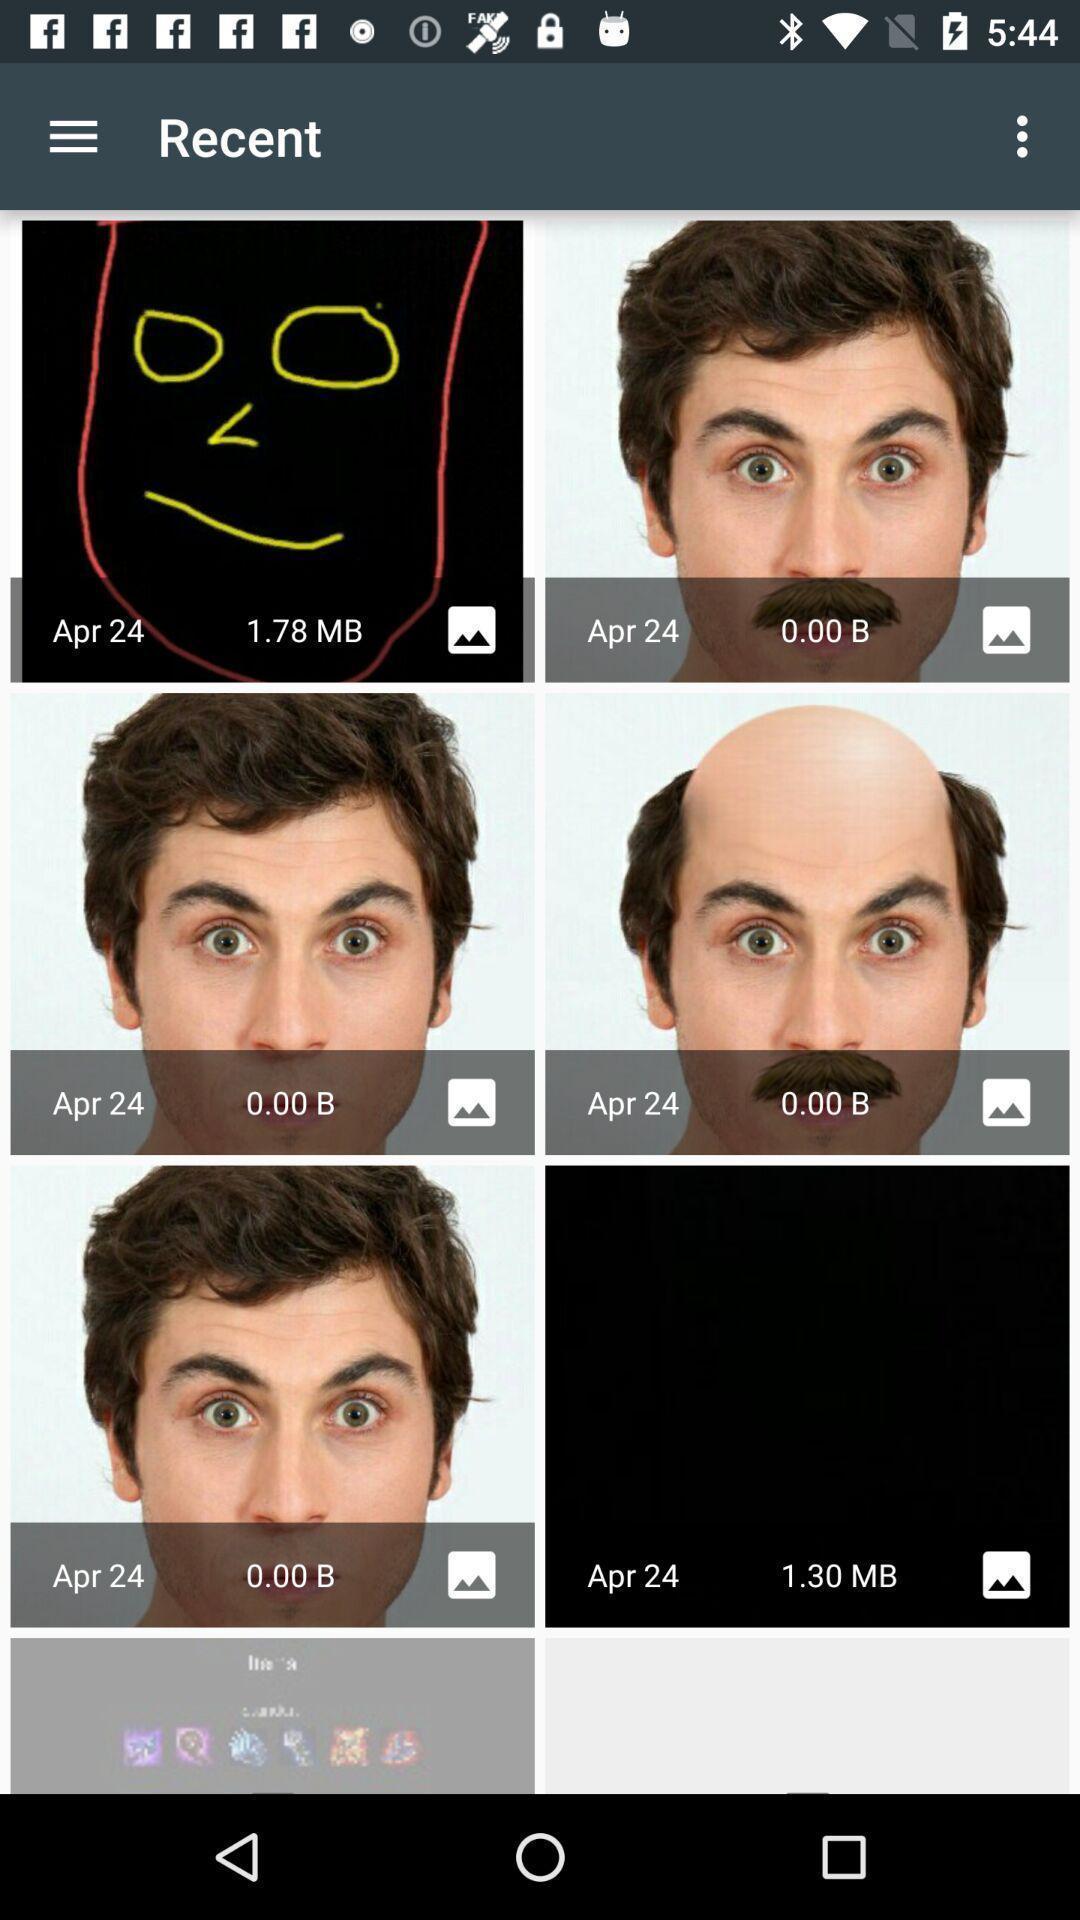Provide a detailed account of this screenshot. Screen shows recent images. 